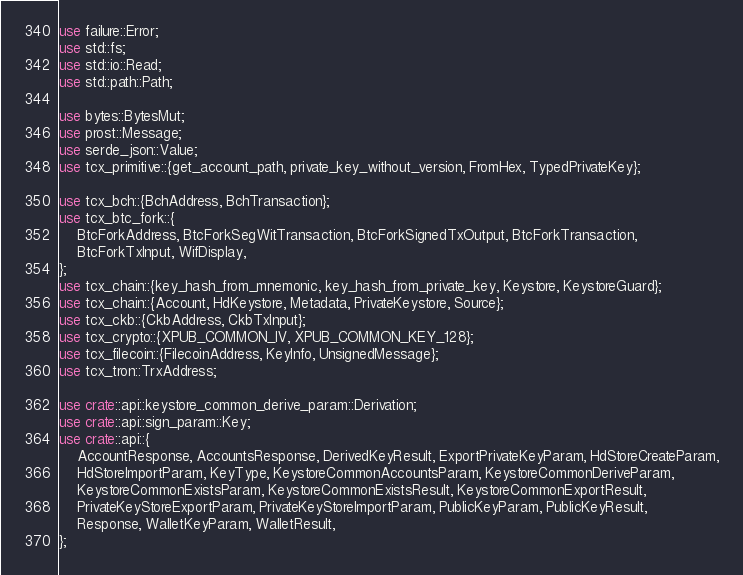<code> <loc_0><loc_0><loc_500><loc_500><_Rust_>use failure::Error;
use std::fs;
use std::io::Read;
use std::path::Path;

use bytes::BytesMut;
use prost::Message;
use serde_json::Value;
use tcx_primitive::{get_account_path, private_key_without_version, FromHex, TypedPrivateKey};

use tcx_bch::{BchAddress, BchTransaction};
use tcx_btc_fork::{
    BtcForkAddress, BtcForkSegWitTransaction, BtcForkSignedTxOutput, BtcForkTransaction,
    BtcForkTxInput, WifDisplay,
};
use tcx_chain::{key_hash_from_mnemonic, key_hash_from_private_key, Keystore, KeystoreGuard};
use tcx_chain::{Account, HdKeystore, Metadata, PrivateKeystore, Source};
use tcx_ckb::{CkbAddress, CkbTxInput};
use tcx_crypto::{XPUB_COMMON_IV, XPUB_COMMON_KEY_128};
use tcx_filecoin::{FilecoinAddress, KeyInfo, UnsignedMessage};
use tcx_tron::TrxAddress;

use crate::api::keystore_common_derive_param::Derivation;
use crate::api::sign_param::Key;
use crate::api::{
    AccountResponse, AccountsResponse, DerivedKeyResult, ExportPrivateKeyParam, HdStoreCreateParam,
    HdStoreImportParam, KeyType, KeystoreCommonAccountsParam, KeystoreCommonDeriveParam,
    KeystoreCommonExistsParam, KeystoreCommonExistsResult, KeystoreCommonExportResult,
    PrivateKeyStoreExportParam, PrivateKeyStoreImportParam, PublicKeyParam, PublicKeyResult,
    Response, WalletKeyParam, WalletResult,
};</code> 